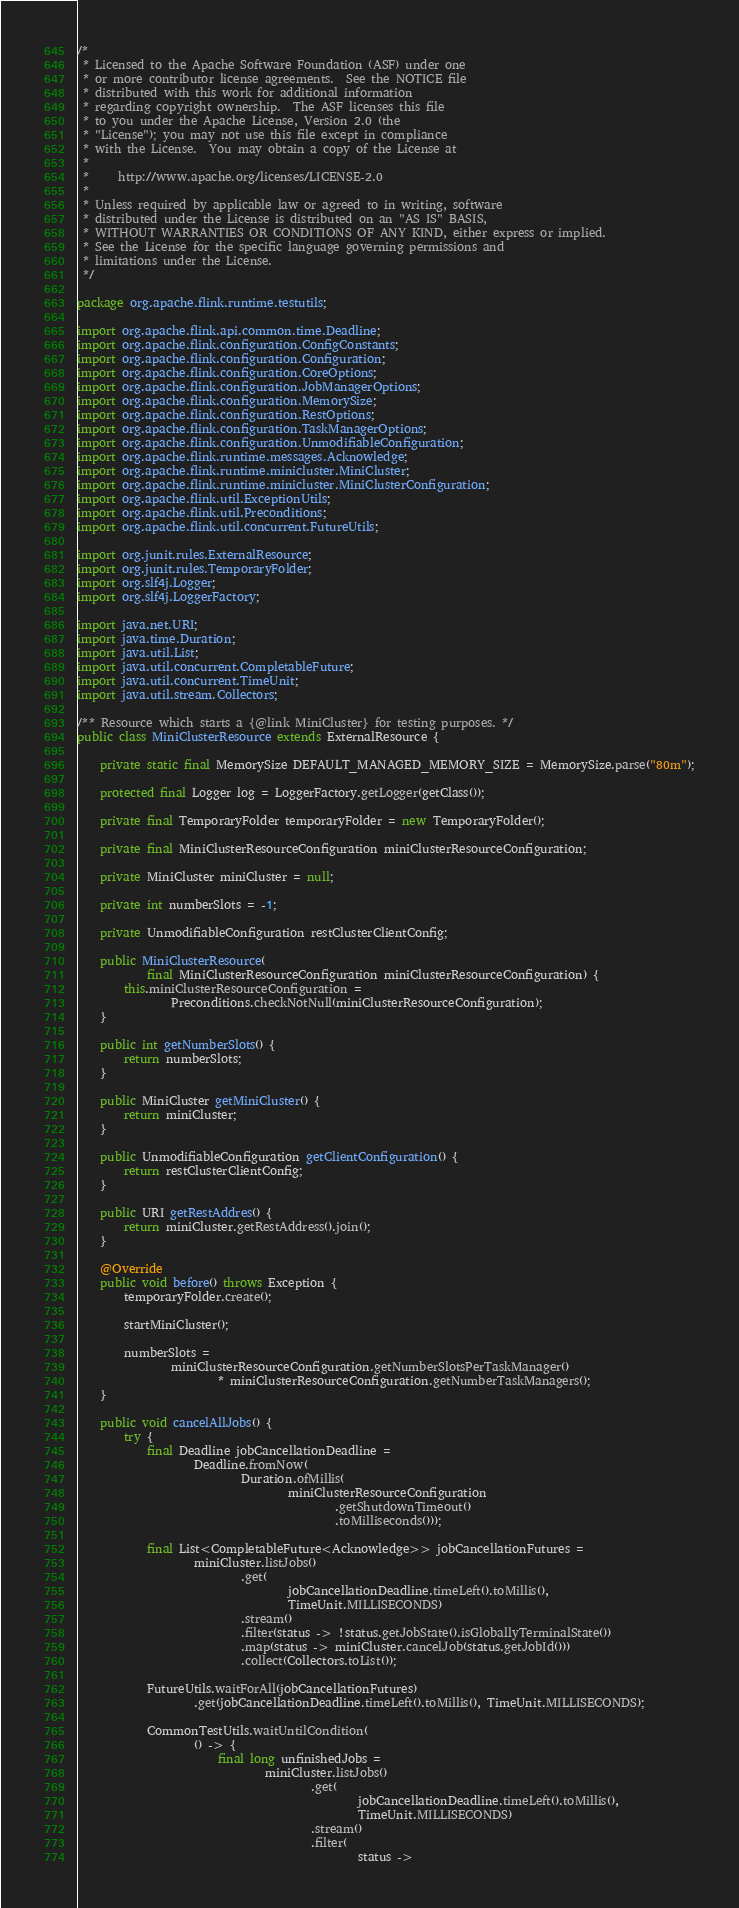<code> <loc_0><loc_0><loc_500><loc_500><_Java_>/*
 * Licensed to the Apache Software Foundation (ASF) under one
 * or more contributor license agreements.  See the NOTICE file
 * distributed with this work for additional information
 * regarding copyright ownership.  The ASF licenses this file
 * to you under the Apache License, Version 2.0 (the
 * "License"); you may not use this file except in compliance
 * with the License.  You may obtain a copy of the License at
 *
 *     http://www.apache.org/licenses/LICENSE-2.0
 *
 * Unless required by applicable law or agreed to in writing, software
 * distributed under the License is distributed on an "AS IS" BASIS,
 * WITHOUT WARRANTIES OR CONDITIONS OF ANY KIND, either express or implied.
 * See the License for the specific language governing permissions and
 * limitations under the License.
 */

package org.apache.flink.runtime.testutils;

import org.apache.flink.api.common.time.Deadline;
import org.apache.flink.configuration.ConfigConstants;
import org.apache.flink.configuration.Configuration;
import org.apache.flink.configuration.CoreOptions;
import org.apache.flink.configuration.JobManagerOptions;
import org.apache.flink.configuration.MemorySize;
import org.apache.flink.configuration.RestOptions;
import org.apache.flink.configuration.TaskManagerOptions;
import org.apache.flink.configuration.UnmodifiableConfiguration;
import org.apache.flink.runtime.messages.Acknowledge;
import org.apache.flink.runtime.minicluster.MiniCluster;
import org.apache.flink.runtime.minicluster.MiniClusterConfiguration;
import org.apache.flink.util.ExceptionUtils;
import org.apache.flink.util.Preconditions;
import org.apache.flink.util.concurrent.FutureUtils;

import org.junit.rules.ExternalResource;
import org.junit.rules.TemporaryFolder;
import org.slf4j.Logger;
import org.slf4j.LoggerFactory;

import java.net.URI;
import java.time.Duration;
import java.util.List;
import java.util.concurrent.CompletableFuture;
import java.util.concurrent.TimeUnit;
import java.util.stream.Collectors;

/** Resource which starts a {@link MiniCluster} for testing purposes. */
public class MiniClusterResource extends ExternalResource {

    private static final MemorySize DEFAULT_MANAGED_MEMORY_SIZE = MemorySize.parse("80m");

    protected final Logger log = LoggerFactory.getLogger(getClass());

    private final TemporaryFolder temporaryFolder = new TemporaryFolder();

    private final MiniClusterResourceConfiguration miniClusterResourceConfiguration;

    private MiniCluster miniCluster = null;

    private int numberSlots = -1;

    private UnmodifiableConfiguration restClusterClientConfig;

    public MiniClusterResource(
            final MiniClusterResourceConfiguration miniClusterResourceConfiguration) {
        this.miniClusterResourceConfiguration =
                Preconditions.checkNotNull(miniClusterResourceConfiguration);
    }

    public int getNumberSlots() {
        return numberSlots;
    }

    public MiniCluster getMiniCluster() {
        return miniCluster;
    }

    public UnmodifiableConfiguration getClientConfiguration() {
        return restClusterClientConfig;
    }

    public URI getRestAddres() {
        return miniCluster.getRestAddress().join();
    }

    @Override
    public void before() throws Exception {
        temporaryFolder.create();

        startMiniCluster();

        numberSlots =
                miniClusterResourceConfiguration.getNumberSlotsPerTaskManager()
                        * miniClusterResourceConfiguration.getNumberTaskManagers();
    }

    public void cancelAllJobs() {
        try {
            final Deadline jobCancellationDeadline =
                    Deadline.fromNow(
                            Duration.ofMillis(
                                    miniClusterResourceConfiguration
                                            .getShutdownTimeout()
                                            .toMilliseconds()));

            final List<CompletableFuture<Acknowledge>> jobCancellationFutures =
                    miniCluster.listJobs()
                            .get(
                                    jobCancellationDeadline.timeLeft().toMillis(),
                                    TimeUnit.MILLISECONDS)
                            .stream()
                            .filter(status -> !status.getJobState().isGloballyTerminalState())
                            .map(status -> miniCluster.cancelJob(status.getJobId()))
                            .collect(Collectors.toList());

            FutureUtils.waitForAll(jobCancellationFutures)
                    .get(jobCancellationDeadline.timeLeft().toMillis(), TimeUnit.MILLISECONDS);

            CommonTestUtils.waitUntilCondition(
                    () -> {
                        final long unfinishedJobs =
                                miniCluster.listJobs()
                                        .get(
                                                jobCancellationDeadline.timeLeft().toMillis(),
                                                TimeUnit.MILLISECONDS)
                                        .stream()
                                        .filter(
                                                status -></code> 